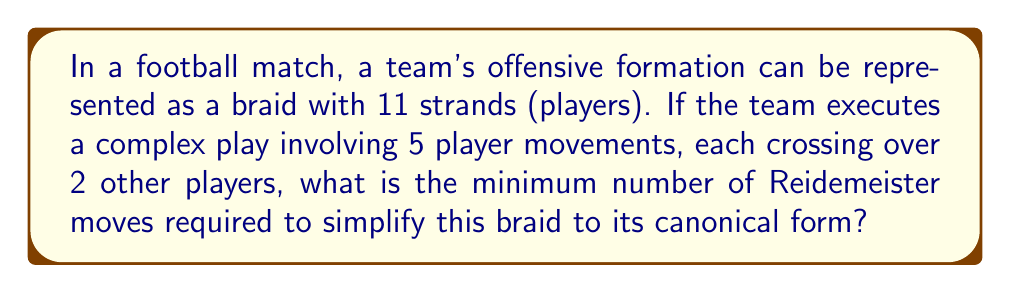Teach me how to tackle this problem. To solve this problem, we need to understand braid theory and Reidemeister moves in the context of football formations:

1. Each player is represented by a strand in the braid.
2. Player movements are represented by strand crossings.
3. Reidemeister moves are used to simplify the braid without changing its fundamental structure.

Given:
- 11 strands (players)
- 5 player movements
- Each movement crosses over 2 other players

Step 1: Calculate the total number of crossings:
$$\text{Total crossings} = 5 \text{ movements} \times 2 \text{ crossings per movement} = 10 \text{ crossings}$$

Step 2: Understand the types of Reidemeister moves:
- Type I: Twist and untwist in a single strand
- Type II: Move one strand completely over another
- Type III: Move a strand over or under a crossing

Step 3: Analyze the player movements:
Since each movement crosses over 2 other players, we can represent this as a series of Type III Reidemeister moves.

Step 4: Determine the minimum number of Reidemeister moves:
Each player movement requires at least one Type III move to simplify. In the best-case scenario, each move can be simplified with a single Reidemeister move.

$$\text{Minimum Reidemeister moves} = \text{Number of player movements} = 5$$

Therefore, the minimum number of Reidemeister moves required to simplify this braid to its canonical form is 5.
Answer: 5 